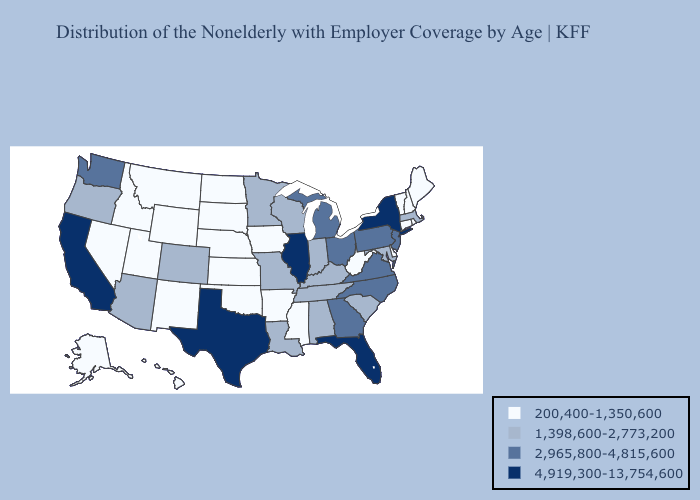Name the states that have a value in the range 2,965,800-4,815,600?
Short answer required. Georgia, Michigan, New Jersey, North Carolina, Ohio, Pennsylvania, Virginia, Washington. Among the states that border Georgia , does Florida have the lowest value?
Answer briefly. No. Name the states that have a value in the range 2,965,800-4,815,600?
Write a very short answer. Georgia, Michigan, New Jersey, North Carolina, Ohio, Pennsylvania, Virginia, Washington. Which states have the lowest value in the South?
Keep it brief. Arkansas, Delaware, Mississippi, Oklahoma, West Virginia. What is the highest value in the MidWest ?
Write a very short answer. 4,919,300-13,754,600. Does Oklahoma have the lowest value in the South?
Short answer required. Yes. Does the map have missing data?
Quick response, please. No. Among the states that border Connecticut , which have the highest value?
Concise answer only. New York. What is the value of Vermont?
Quick response, please. 200,400-1,350,600. Which states have the lowest value in the Northeast?
Short answer required. Connecticut, Maine, New Hampshire, Rhode Island, Vermont. What is the highest value in states that border New Hampshire?
Give a very brief answer. 1,398,600-2,773,200. Name the states that have a value in the range 200,400-1,350,600?
Concise answer only. Alaska, Arkansas, Connecticut, Delaware, Hawaii, Idaho, Iowa, Kansas, Maine, Mississippi, Montana, Nebraska, Nevada, New Hampshire, New Mexico, North Dakota, Oklahoma, Rhode Island, South Dakota, Utah, Vermont, West Virginia, Wyoming. Name the states that have a value in the range 1,398,600-2,773,200?
Quick response, please. Alabama, Arizona, Colorado, Indiana, Kentucky, Louisiana, Maryland, Massachusetts, Minnesota, Missouri, Oregon, South Carolina, Tennessee, Wisconsin. Name the states that have a value in the range 2,965,800-4,815,600?
Keep it brief. Georgia, Michigan, New Jersey, North Carolina, Ohio, Pennsylvania, Virginia, Washington. What is the value of Colorado?
Write a very short answer. 1,398,600-2,773,200. 